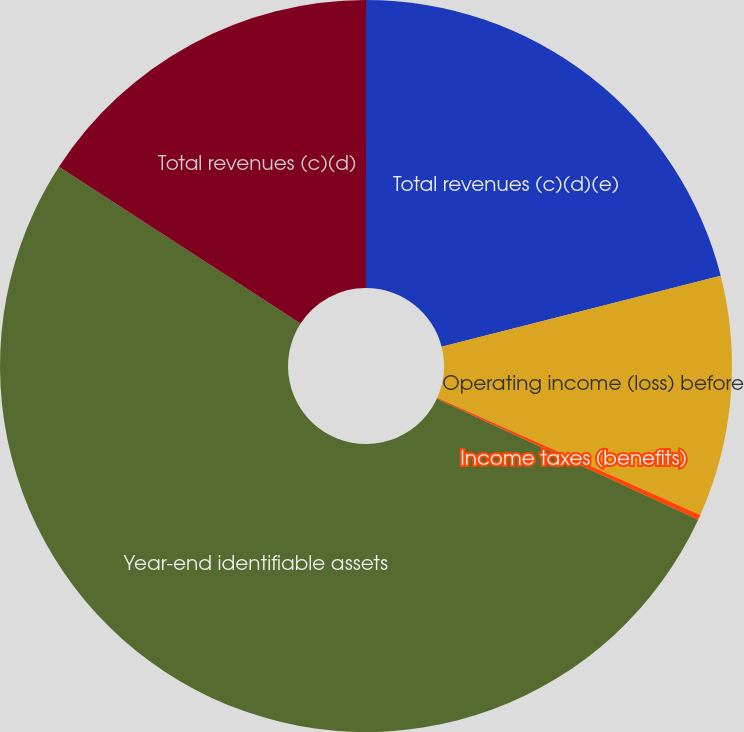<chart> <loc_0><loc_0><loc_500><loc_500><pie_chart><fcel>Total revenues (c)(d)(e)<fcel>Operating income (loss) before<fcel>Income taxes (benefits)<fcel>Year-end identifiable assets<fcel>Total revenues (c)(d)<nl><fcel>21.04%<fcel>10.63%<fcel>0.23%<fcel>52.26%<fcel>15.84%<nl></chart> 